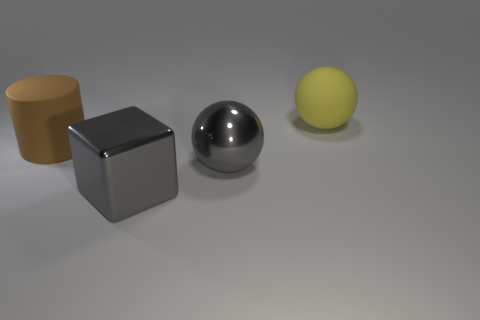What is the size of the metal object that is the same color as the shiny ball?
Your response must be concise. Large. The big sphere that is made of the same material as the large block is what color?
Give a very brief answer. Gray. What number of objects are either large objects behind the brown rubber thing or gray metal objects?
Offer a terse response. 3. The large matte object in front of the ball that is behind the large brown rubber object is what color?
Your response must be concise. Brown. How many other objects are the same color as the big rubber ball?
Your answer should be compact. 0. Is the number of big metal cubes that are to the right of the big brown cylinder greater than the number of gray blocks right of the large yellow sphere?
Make the answer very short. Yes. What number of big cylinders are behind the metallic thing behind the cube?
Keep it short and to the point. 1. Is the shape of the matte object that is left of the large yellow rubber sphere the same as  the yellow rubber object?
Offer a very short reply. No. What is the material of the big gray thing that is the same shape as the large yellow thing?
Offer a very short reply. Metal. What number of brown matte cylinders are the same size as the rubber ball?
Provide a succinct answer. 1. 